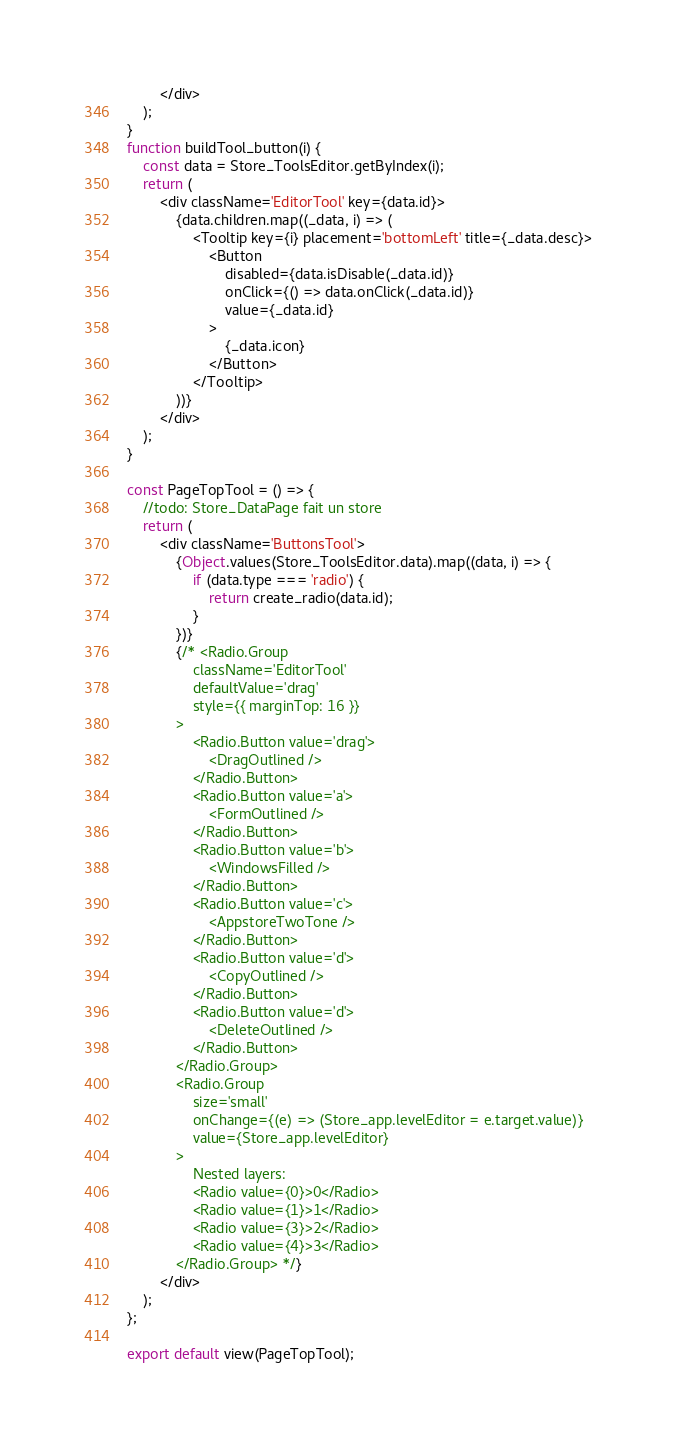<code> <loc_0><loc_0><loc_500><loc_500><_JavaScript_>		</div>
	);
}
function buildTool_button(i) {
	const data = Store_ToolsEditor.getByIndex(i);
	return (
		<div className='EditorTool' key={data.id}>
			{data.children.map((_data, i) => (
				<Tooltip key={i} placement='bottomLeft' title={_data.desc}>
					<Button
						disabled={data.isDisable(_data.id)}
						onClick={() => data.onClick(_data.id)}
						value={_data.id}
					>
						{_data.icon}
					</Button>
				</Tooltip>
			))}
		</div>
	);
}

const PageTopTool = () => {
	//todo: Store_DataPage fait un store
	return (
		<div className='ButtonsTool'>
			{Object.values(Store_ToolsEditor.data).map((data, i) => {
				if (data.type === 'radio') {
					return create_radio(data.id);
				}
			})}
			{/* <Radio.Group
				className='EditorTool'
				defaultValue='drag'
				style={{ marginTop: 16 }}
			>
				<Radio.Button value='drag'>
					<DragOutlined />
				</Radio.Button>
				<Radio.Button value='a'>
					<FormOutlined />
				</Radio.Button>
				<Radio.Button value='b'>
					<WindowsFilled />
				</Radio.Button>
				<Radio.Button value='c'>
					<AppstoreTwoTone />
				</Radio.Button>
				<Radio.Button value='d'>
					<CopyOutlined />
				</Radio.Button>
				<Radio.Button value='d'>
					<DeleteOutlined />
				</Radio.Button>
			</Radio.Group>
			<Radio.Group
				size='small'
				onChange={(e) => (Store_app.levelEditor = e.target.value)}
				value={Store_app.levelEditor}
			>
				Nested layers:
				<Radio value={0}>0</Radio>
				<Radio value={1}>1</Radio>
				<Radio value={3}>2</Radio>
				<Radio value={4}>3</Radio>
			</Radio.Group> */}
		</div>
	);
};

export default view(PageTopTool);
</code> 